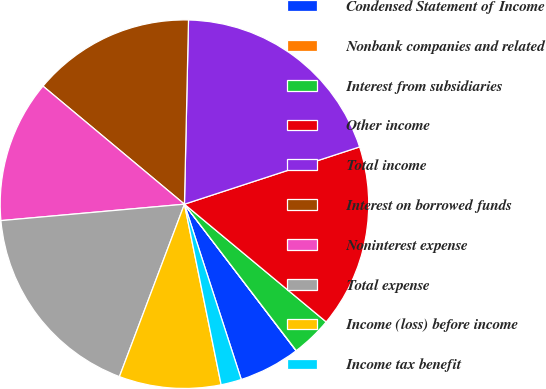<chart> <loc_0><loc_0><loc_500><loc_500><pie_chart><fcel>Condensed Statement of Income<fcel>Nonbank companies and related<fcel>Interest from subsidiaries<fcel>Other income<fcel>Total income<fcel>Interest on borrowed funds<fcel>Noninterest expense<fcel>Total expense<fcel>Income (loss) before income<fcel>Income tax benefit<nl><fcel>5.37%<fcel>0.02%<fcel>3.59%<fcel>16.06%<fcel>19.62%<fcel>14.28%<fcel>12.49%<fcel>17.84%<fcel>8.93%<fcel>1.8%<nl></chart> 